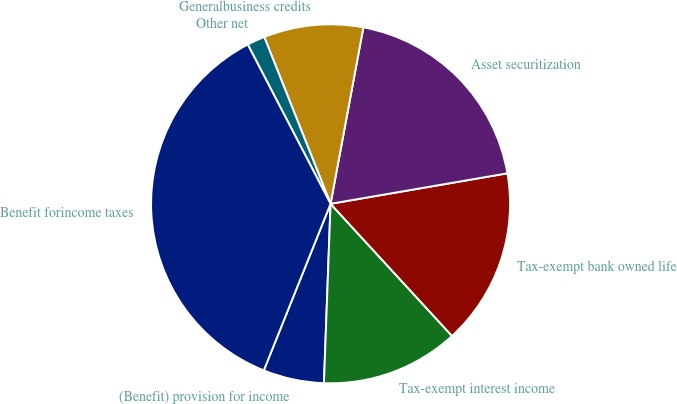<chart> <loc_0><loc_0><loc_500><loc_500><pie_chart><fcel>(Benefit) provision for income<fcel>Tax-exempt interest income<fcel>Tax-exempt bank owned life<fcel>Asset securitization<fcel>Generalbusiness credits<fcel>Other net<fcel>Benefit forincome taxes<nl><fcel>5.48%<fcel>12.42%<fcel>15.89%<fcel>19.36%<fcel>8.95%<fcel>1.61%<fcel>36.31%<nl></chart> 